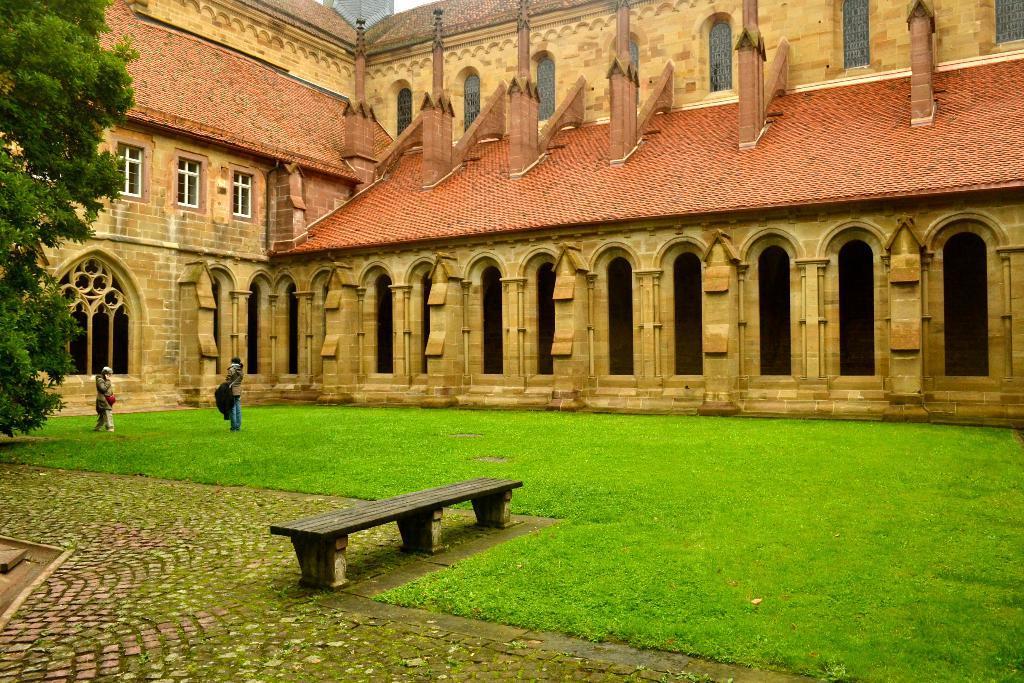Please provide a concise description of this image. In this picture we can see persons on the ground, here we can see a bench, grass and in the background we can see a building, trees. 